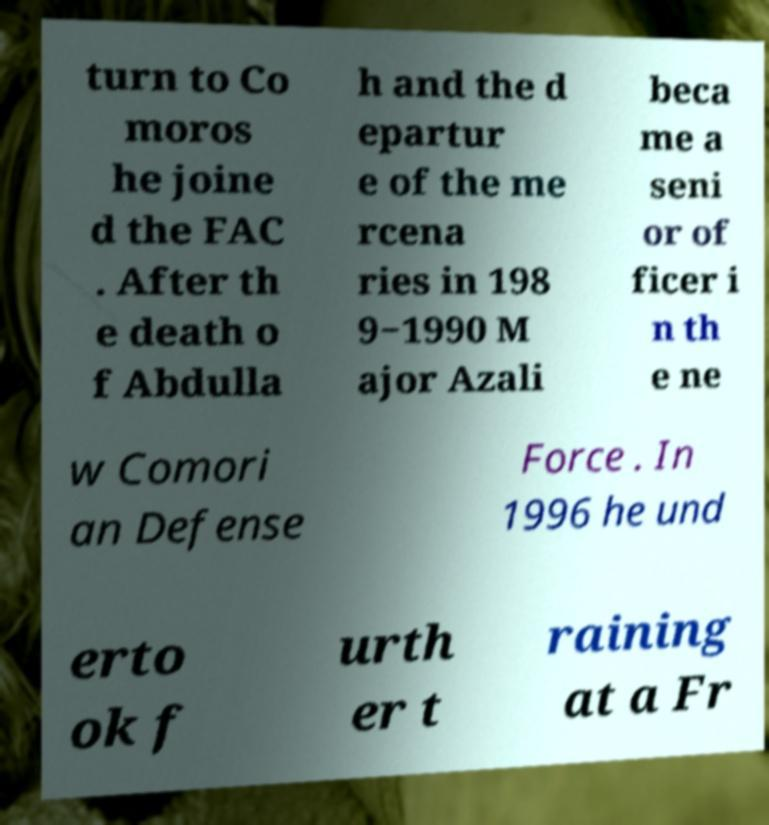Please read and relay the text visible in this image. What does it say? turn to Co moros he joine d the FAC . After th e death o f Abdulla h and the d epartur e of the me rcena ries in 198 9−1990 M ajor Azali beca me a seni or of ficer i n th e ne w Comori an Defense Force . In 1996 he und erto ok f urth er t raining at a Fr 